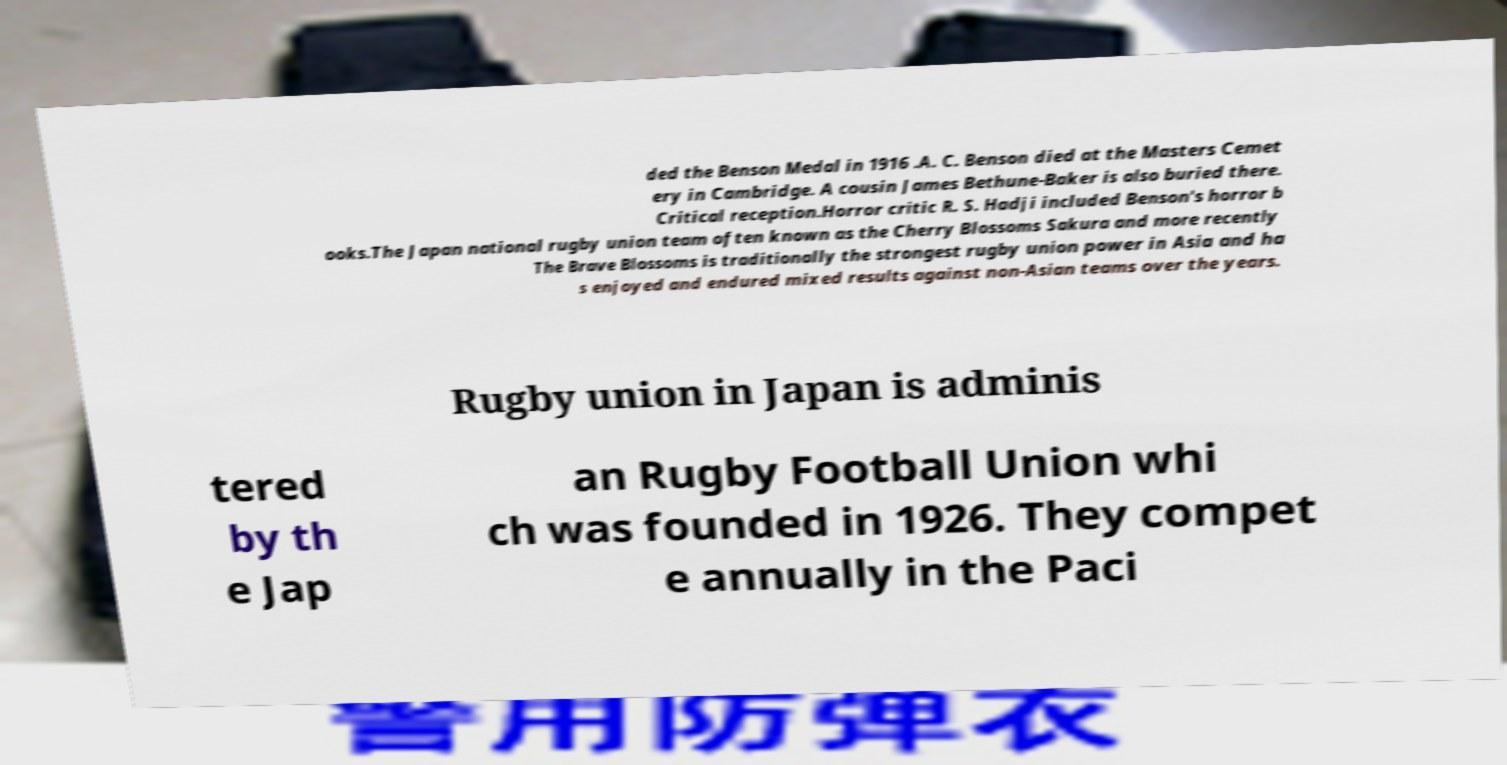For documentation purposes, I need the text within this image transcribed. Could you provide that? ded the Benson Medal in 1916 .A. C. Benson died at the Masters Cemet ery in Cambridge. A cousin James Bethune-Baker is also buried there. Critical reception.Horror critic R. S. Hadji included Benson's horror b ooks.The Japan national rugby union team often known as the Cherry Blossoms Sakura and more recently The Brave Blossoms is traditionally the strongest rugby union power in Asia and ha s enjoyed and endured mixed results against non-Asian teams over the years. Rugby union in Japan is adminis tered by th e Jap an Rugby Football Union whi ch was founded in 1926. They compet e annually in the Paci 